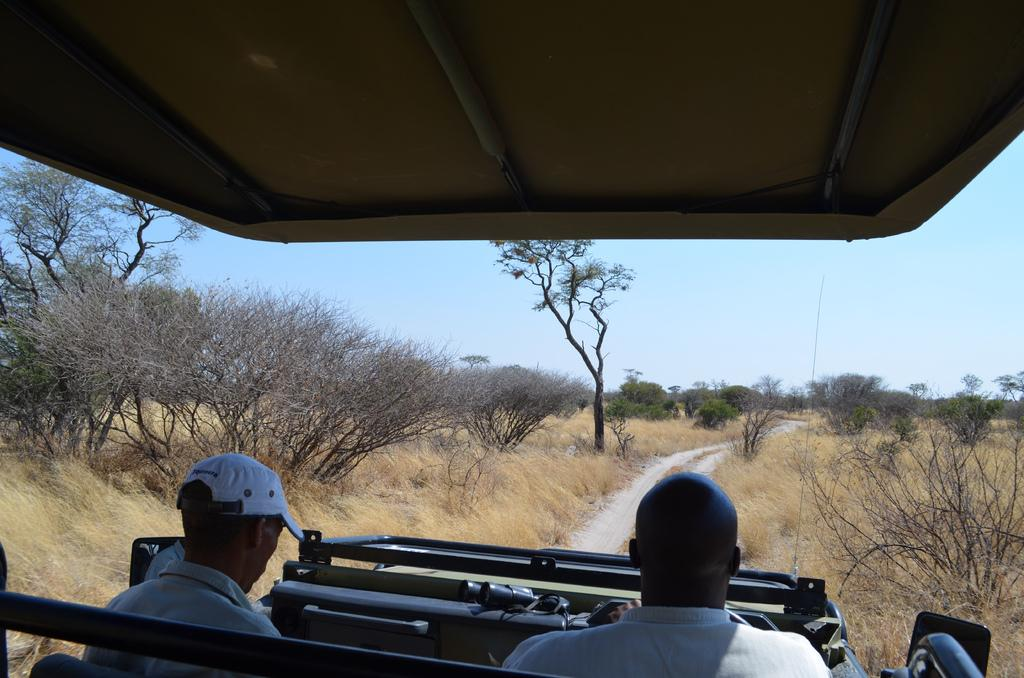How many people are in the vehicle in the image? There are two persons in the vehicle in the image. Where is the vehicle located in the image? The vehicle is at the bottom of the image. What type of landscape can be seen in the background of the image? There is a grassy land and trees in the background of the image. What is visible above the vehicle in the image? There is a sky visible in the image. How many ladybugs can be seen crawling on the potato in the image? There are no ladybugs or potatoes present in the image. What type of cough medicine is visible in the image? There is no cough medicine present in the image. 